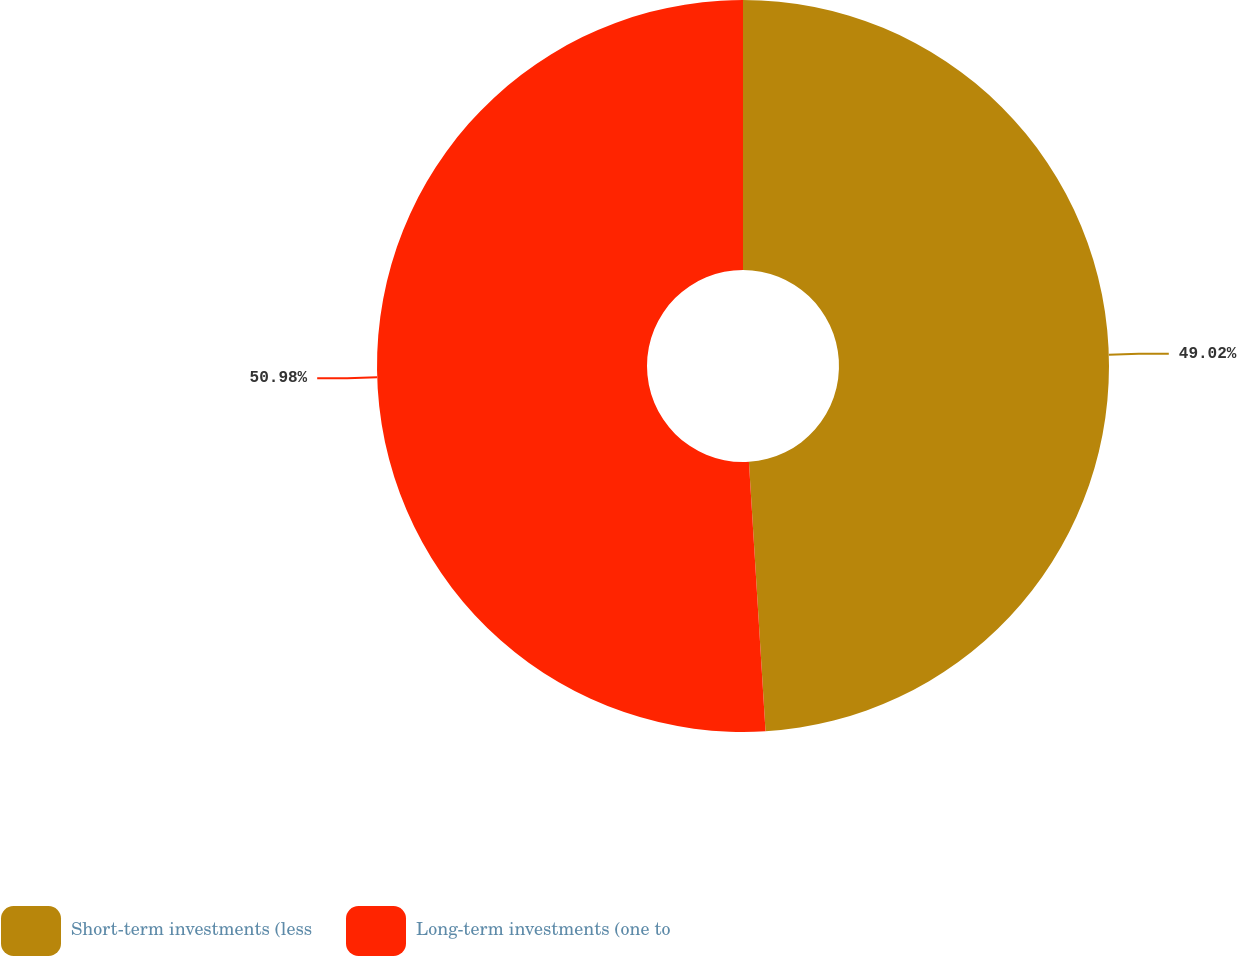<chart> <loc_0><loc_0><loc_500><loc_500><pie_chart><fcel>Short-term investments (less<fcel>Long-term investments (one to<nl><fcel>49.02%<fcel>50.98%<nl></chart> 